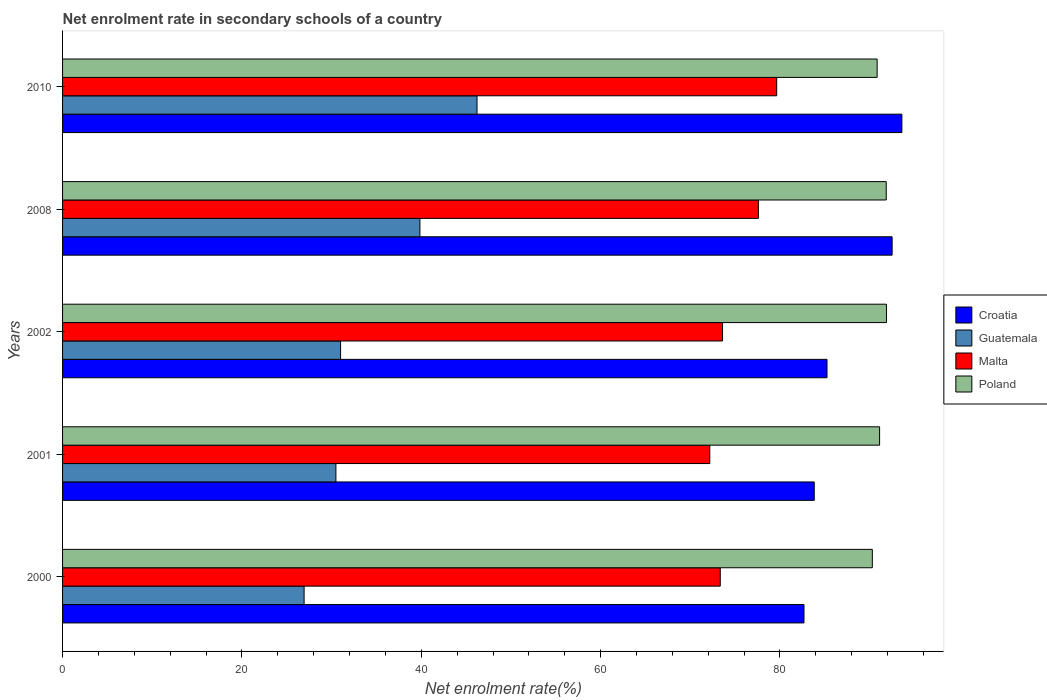How many different coloured bars are there?
Provide a short and direct response. 4. Are the number of bars per tick equal to the number of legend labels?
Make the answer very short. Yes. How many bars are there on the 3rd tick from the top?
Your response must be concise. 4. In how many cases, is the number of bars for a given year not equal to the number of legend labels?
Your response must be concise. 0. What is the net enrolment rate in secondary schools in Croatia in 2008?
Provide a succinct answer. 92.51. Across all years, what is the maximum net enrolment rate in secondary schools in Malta?
Offer a terse response. 79.63. Across all years, what is the minimum net enrolment rate in secondary schools in Malta?
Ensure brevity in your answer.  72.17. In which year was the net enrolment rate in secondary schools in Croatia minimum?
Offer a terse response. 2000. What is the total net enrolment rate in secondary schools in Croatia in the graph?
Provide a short and direct response. 437.85. What is the difference between the net enrolment rate in secondary schools in Guatemala in 2002 and that in 2008?
Give a very brief answer. -8.85. What is the difference between the net enrolment rate in secondary schools in Poland in 2008 and the net enrolment rate in secondary schools in Croatia in 2002?
Keep it short and to the point. 6.6. What is the average net enrolment rate in secondary schools in Malta per year?
Make the answer very short. 75.27. In the year 2008, what is the difference between the net enrolment rate in secondary schools in Poland and net enrolment rate in secondary schools in Malta?
Provide a succinct answer. 14.26. What is the ratio of the net enrolment rate in secondary schools in Poland in 2000 to that in 2008?
Ensure brevity in your answer.  0.98. Is the net enrolment rate in secondary schools in Malta in 2008 less than that in 2010?
Offer a terse response. Yes. Is the difference between the net enrolment rate in secondary schools in Poland in 2001 and 2010 greater than the difference between the net enrolment rate in secondary schools in Malta in 2001 and 2010?
Your answer should be very brief. Yes. What is the difference between the highest and the second highest net enrolment rate in secondary schools in Poland?
Give a very brief answer. 0.03. What is the difference between the highest and the lowest net enrolment rate in secondary schools in Malta?
Offer a terse response. 7.46. In how many years, is the net enrolment rate in secondary schools in Poland greater than the average net enrolment rate in secondary schools in Poland taken over all years?
Your response must be concise. 2. Is it the case that in every year, the sum of the net enrolment rate in secondary schools in Malta and net enrolment rate in secondary schools in Poland is greater than the sum of net enrolment rate in secondary schools in Croatia and net enrolment rate in secondary schools in Guatemala?
Provide a short and direct response. Yes. What does the 2nd bar from the top in 2002 represents?
Give a very brief answer. Malta. What does the 3rd bar from the bottom in 2002 represents?
Your response must be concise. Malta. Is it the case that in every year, the sum of the net enrolment rate in secondary schools in Guatemala and net enrolment rate in secondary schools in Croatia is greater than the net enrolment rate in secondary schools in Poland?
Your response must be concise. Yes. Are all the bars in the graph horizontal?
Ensure brevity in your answer.  Yes. What is the difference between two consecutive major ticks on the X-axis?
Your answer should be compact. 20. Are the values on the major ticks of X-axis written in scientific E-notation?
Ensure brevity in your answer.  No. Does the graph contain any zero values?
Your response must be concise. No. Does the graph contain grids?
Provide a succinct answer. No. How are the legend labels stacked?
Offer a terse response. Vertical. What is the title of the graph?
Provide a succinct answer. Net enrolment rate in secondary schools of a country. Does "Other small states" appear as one of the legend labels in the graph?
Your answer should be compact. No. What is the label or title of the X-axis?
Offer a terse response. Net enrolment rate(%). What is the Net enrolment rate(%) in Croatia in 2000?
Your answer should be compact. 82.68. What is the Net enrolment rate(%) of Guatemala in 2000?
Your answer should be compact. 26.94. What is the Net enrolment rate(%) of Malta in 2000?
Your answer should be compact. 73.34. What is the Net enrolment rate(%) in Poland in 2000?
Give a very brief answer. 90.3. What is the Net enrolment rate(%) in Croatia in 2001?
Make the answer very short. 83.82. What is the Net enrolment rate(%) in Guatemala in 2001?
Give a very brief answer. 30.48. What is the Net enrolment rate(%) of Malta in 2001?
Keep it short and to the point. 72.17. What is the Net enrolment rate(%) in Poland in 2001?
Your response must be concise. 91.11. What is the Net enrolment rate(%) of Croatia in 2002?
Offer a very short reply. 85.25. What is the Net enrolment rate(%) in Guatemala in 2002?
Give a very brief answer. 31. What is the Net enrolment rate(%) of Malta in 2002?
Your response must be concise. 73.6. What is the Net enrolment rate(%) of Poland in 2002?
Offer a terse response. 91.88. What is the Net enrolment rate(%) in Croatia in 2008?
Give a very brief answer. 92.51. What is the Net enrolment rate(%) of Guatemala in 2008?
Make the answer very short. 39.85. What is the Net enrolment rate(%) of Malta in 2008?
Your answer should be compact. 77.59. What is the Net enrolment rate(%) of Poland in 2008?
Offer a terse response. 91.85. What is the Net enrolment rate(%) of Croatia in 2010?
Provide a short and direct response. 93.59. What is the Net enrolment rate(%) of Guatemala in 2010?
Your response must be concise. 46.22. What is the Net enrolment rate(%) of Malta in 2010?
Offer a very short reply. 79.63. What is the Net enrolment rate(%) of Poland in 2010?
Keep it short and to the point. 90.84. Across all years, what is the maximum Net enrolment rate(%) in Croatia?
Give a very brief answer. 93.59. Across all years, what is the maximum Net enrolment rate(%) of Guatemala?
Provide a short and direct response. 46.22. Across all years, what is the maximum Net enrolment rate(%) of Malta?
Provide a short and direct response. 79.63. Across all years, what is the maximum Net enrolment rate(%) of Poland?
Your answer should be compact. 91.88. Across all years, what is the minimum Net enrolment rate(%) in Croatia?
Ensure brevity in your answer.  82.68. Across all years, what is the minimum Net enrolment rate(%) of Guatemala?
Keep it short and to the point. 26.94. Across all years, what is the minimum Net enrolment rate(%) of Malta?
Give a very brief answer. 72.17. Across all years, what is the minimum Net enrolment rate(%) in Poland?
Give a very brief answer. 90.3. What is the total Net enrolment rate(%) of Croatia in the graph?
Your answer should be very brief. 437.85. What is the total Net enrolment rate(%) of Guatemala in the graph?
Ensure brevity in your answer.  174.49. What is the total Net enrolment rate(%) in Malta in the graph?
Provide a short and direct response. 376.34. What is the total Net enrolment rate(%) of Poland in the graph?
Keep it short and to the point. 455.97. What is the difference between the Net enrolment rate(%) of Croatia in 2000 and that in 2001?
Offer a terse response. -1.14. What is the difference between the Net enrolment rate(%) of Guatemala in 2000 and that in 2001?
Your answer should be compact. -3.55. What is the difference between the Net enrolment rate(%) of Malta in 2000 and that in 2001?
Provide a succinct answer. 1.17. What is the difference between the Net enrolment rate(%) of Poland in 2000 and that in 2001?
Offer a terse response. -0.81. What is the difference between the Net enrolment rate(%) in Croatia in 2000 and that in 2002?
Your answer should be compact. -2.57. What is the difference between the Net enrolment rate(%) in Guatemala in 2000 and that in 2002?
Give a very brief answer. -4.07. What is the difference between the Net enrolment rate(%) of Malta in 2000 and that in 2002?
Keep it short and to the point. -0.25. What is the difference between the Net enrolment rate(%) of Poland in 2000 and that in 2002?
Make the answer very short. -1.58. What is the difference between the Net enrolment rate(%) in Croatia in 2000 and that in 2008?
Keep it short and to the point. -9.83. What is the difference between the Net enrolment rate(%) of Guatemala in 2000 and that in 2008?
Give a very brief answer. -12.91. What is the difference between the Net enrolment rate(%) of Malta in 2000 and that in 2008?
Offer a terse response. -4.25. What is the difference between the Net enrolment rate(%) in Poland in 2000 and that in 2008?
Give a very brief answer. -1.55. What is the difference between the Net enrolment rate(%) in Croatia in 2000 and that in 2010?
Your answer should be very brief. -10.91. What is the difference between the Net enrolment rate(%) of Guatemala in 2000 and that in 2010?
Offer a very short reply. -19.28. What is the difference between the Net enrolment rate(%) of Malta in 2000 and that in 2010?
Provide a succinct answer. -6.29. What is the difference between the Net enrolment rate(%) of Poland in 2000 and that in 2010?
Make the answer very short. -0.54. What is the difference between the Net enrolment rate(%) in Croatia in 2001 and that in 2002?
Your response must be concise. -1.42. What is the difference between the Net enrolment rate(%) of Guatemala in 2001 and that in 2002?
Your answer should be compact. -0.52. What is the difference between the Net enrolment rate(%) of Malta in 2001 and that in 2002?
Provide a succinct answer. -1.42. What is the difference between the Net enrolment rate(%) of Poland in 2001 and that in 2002?
Offer a very short reply. -0.77. What is the difference between the Net enrolment rate(%) of Croatia in 2001 and that in 2008?
Ensure brevity in your answer.  -8.69. What is the difference between the Net enrolment rate(%) of Guatemala in 2001 and that in 2008?
Provide a succinct answer. -9.37. What is the difference between the Net enrolment rate(%) of Malta in 2001 and that in 2008?
Give a very brief answer. -5.42. What is the difference between the Net enrolment rate(%) in Poland in 2001 and that in 2008?
Keep it short and to the point. -0.74. What is the difference between the Net enrolment rate(%) of Croatia in 2001 and that in 2010?
Make the answer very short. -9.77. What is the difference between the Net enrolment rate(%) of Guatemala in 2001 and that in 2010?
Offer a terse response. -15.74. What is the difference between the Net enrolment rate(%) of Malta in 2001 and that in 2010?
Offer a terse response. -7.46. What is the difference between the Net enrolment rate(%) in Poland in 2001 and that in 2010?
Provide a short and direct response. 0.27. What is the difference between the Net enrolment rate(%) in Croatia in 2002 and that in 2008?
Make the answer very short. -7.26. What is the difference between the Net enrolment rate(%) in Guatemala in 2002 and that in 2008?
Ensure brevity in your answer.  -8.85. What is the difference between the Net enrolment rate(%) of Malta in 2002 and that in 2008?
Keep it short and to the point. -4. What is the difference between the Net enrolment rate(%) of Poland in 2002 and that in 2008?
Provide a succinct answer. 0.03. What is the difference between the Net enrolment rate(%) in Croatia in 2002 and that in 2010?
Offer a terse response. -8.35. What is the difference between the Net enrolment rate(%) of Guatemala in 2002 and that in 2010?
Offer a very short reply. -15.22. What is the difference between the Net enrolment rate(%) in Malta in 2002 and that in 2010?
Make the answer very short. -6.04. What is the difference between the Net enrolment rate(%) of Poland in 2002 and that in 2010?
Offer a very short reply. 1.04. What is the difference between the Net enrolment rate(%) in Croatia in 2008 and that in 2010?
Offer a terse response. -1.09. What is the difference between the Net enrolment rate(%) in Guatemala in 2008 and that in 2010?
Provide a succinct answer. -6.37. What is the difference between the Net enrolment rate(%) in Malta in 2008 and that in 2010?
Provide a short and direct response. -2.04. What is the difference between the Net enrolment rate(%) of Poland in 2008 and that in 2010?
Offer a terse response. 1.01. What is the difference between the Net enrolment rate(%) in Croatia in 2000 and the Net enrolment rate(%) in Guatemala in 2001?
Keep it short and to the point. 52.2. What is the difference between the Net enrolment rate(%) in Croatia in 2000 and the Net enrolment rate(%) in Malta in 2001?
Give a very brief answer. 10.51. What is the difference between the Net enrolment rate(%) in Croatia in 2000 and the Net enrolment rate(%) in Poland in 2001?
Provide a short and direct response. -8.43. What is the difference between the Net enrolment rate(%) of Guatemala in 2000 and the Net enrolment rate(%) of Malta in 2001?
Provide a short and direct response. -45.24. What is the difference between the Net enrolment rate(%) of Guatemala in 2000 and the Net enrolment rate(%) of Poland in 2001?
Offer a terse response. -64.17. What is the difference between the Net enrolment rate(%) in Malta in 2000 and the Net enrolment rate(%) in Poland in 2001?
Offer a very short reply. -17.77. What is the difference between the Net enrolment rate(%) in Croatia in 2000 and the Net enrolment rate(%) in Guatemala in 2002?
Your response must be concise. 51.68. What is the difference between the Net enrolment rate(%) in Croatia in 2000 and the Net enrolment rate(%) in Malta in 2002?
Provide a short and direct response. 9.08. What is the difference between the Net enrolment rate(%) of Croatia in 2000 and the Net enrolment rate(%) of Poland in 2002?
Offer a terse response. -9.2. What is the difference between the Net enrolment rate(%) of Guatemala in 2000 and the Net enrolment rate(%) of Malta in 2002?
Give a very brief answer. -46.66. What is the difference between the Net enrolment rate(%) of Guatemala in 2000 and the Net enrolment rate(%) of Poland in 2002?
Give a very brief answer. -64.94. What is the difference between the Net enrolment rate(%) of Malta in 2000 and the Net enrolment rate(%) of Poland in 2002?
Your response must be concise. -18.53. What is the difference between the Net enrolment rate(%) in Croatia in 2000 and the Net enrolment rate(%) in Guatemala in 2008?
Keep it short and to the point. 42.83. What is the difference between the Net enrolment rate(%) of Croatia in 2000 and the Net enrolment rate(%) of Malta in 2008?
Offer a very short reply. 5.09. What is the difference between the Net enrolment rate(%) of Croatia in 2000 and the Net enrolment rate(%) of Poland in 2008?
Make the answer very short. -9.17. What is the difference between the Net enrolment rate(%) of Guatemala in 2000 and the Net enrolment rate(%) of Malta in 2008?
Your answer should be very brief. -50.66. What is the difference between the Net enrolment rate(%) of Guatemala in 2000 and the Net enrolment rate(%) of Poland in 2008?
Give a very brief answer. -64.91. What is the difference between the Net enrolment rate(%) in Malta in 2000 and the Net enrolment rate(%) in Poland in 2008?
Your answer should be compact. -18.51. What is the difference between the Net enrolment rate(%) of Croatia in 2000 and the Net enrolment rate(%) of Guatemala in 2010?
Provide a succinct answer. 36.46. What is the difference between the Net enrolment rate(%) in Croatia in 2000 and the Net enrolment rate(%) in Malta in 2010?
Make the answer very short. 3.04. What is the difference between the Net enrolment rate(%) in Croatia in 2000 and the Net enrolment rate(%) in Poland in 2010?
Give a very brief answer. -8.16. What is the difference between the Net enrolment rate(%) of Guatemala in 2000 and the Net enrolment rate(%) of Malta in 2010?
Your response must be concise. -52.7. What is the difference between the Net enrolment rate(%) in Guatemala in 2000 and the Net enrolment rate(%) in Poland in 2010?
Give a very brief answer. -63.9. What is the difference between the Net enrolment rate(%) of Malta in 2000 and the Net enrolment rate(%) of Poland in 2010?
Your response must be concise. -17.49. What is the difference between the Net enrolment rate(%) of Croatia in 2001 and the Net enrolment rate(%) of Guatemala in 2002?
Your response must be concise. 52.82. What is the difference between the Net enrolment rate(%) of Croatia in 2001 and the Net enrolment rate(%) of Malta in 2002?
Make the answer very short. 10.23. What is the difference between the Net enrolment rate(%) in Croatia in 2001 and the Net enrolment rate(%) in Poland in 2002?
Make the answer very short. -8.05. What is the difference between the Net enrolment rate(%) of Guatemala in 2001 and the Net enrolment rate(%) of Malta in 2002?
Provide a short and direct response. -43.11. What is the difference between the Net enrolment rate(%) of Guatemala in 2001 and the Net enrolment rate(%) of Poland in 2002?
Keep it short and to the point. -61.39. What is the difference between the Net enrolment rate(%) of Malta in 2001 and the Net enrolment rate(%) of Poland in 2002?
Your answer should be compact. -19.7. What is the difference between the Net enrolment rate(%) of Croatia in 2001 and the Net enrolment rate(%) of Guatemala in 2008?
Provide a succinct answer. 43.97. What is the difference between the Net enrolment rate(%) of Croatia in 2001 and the Net enrolment rate(%) of Malta in 2008?
Offer a very short reply. 6.23. What is the difference between the Net enrolment rate(%) of Croatia in 2001 and the Net enrolment rate(%) of Poland in 2008?
Your response must be concise. -8.03. What is the difference between the Net enrolment rate(%) in Guatemala in 2001 and the Net enrolment rate(%) in Malta in 2008?
Your response must be concise. -47.11. What is the difference between the Net enrolment rate(%) of Guatemala in 2001 and the Net enrolment rate(%) of Poland in 2008?
Offer a very short reply. -61.37. What is the difference between the Net enrolment rate(%) in Malta in 2001 and the Net enrolment rate(%) in Poland in 2008?
Your response must be concise. -19.68. What is the difference between the Net enrolment rate(%) of Croatia in 2001 and the Net enrolment rate(%) of Guatemala in 2010?
Provide a succinct answer. 37.61. What is the difference between the Net enrolment rate(%) of Croatia in 2001 and the Net enrolment rate(%) of Malta in 2010?
Ensure brevity in your answer.  4.19. What is the difference between the Net enrolment rate(%) of Croatia in 2001 and the Net enrolment rate(%) of Poland in 2010?
Ensure brevity in your answer.  -7.01. What is the difference between the Net enrolment rate(%) of Guatemala in 2001 and the Net enrolment rate(%) of Malta in 2010?
Give a very brief answer. -49.15. What is the difference between the Net enrolment rate(%) in Guatemala in 2001 and the Net enrolment rate(%) in Poland in 2010?
Make the answer very short. -60.35. What is the difference between the Net enrolment rate(%) of Malta in 2001 and the Net enrolment rate(%) of Poland in 2010?
Your answer should be very brief. -18.66. What is the difference between the Net enrolment rate(%) of Croatia in 2002 and the Net enrolment rate(%) of Guatemala in 2008?
Your answer should be compact. 45.4. What is the difference between the Net enrolment rate(%) of Croatia in 2002 and the Net enrolment rate(%) of Malta in 2008?
Your answer should be very brief. 7.65. What is the difference between the Net enrolment rate(%) of Croatia in 2002 and the Net enrolment rate(%) of Poland in 2008?
Ensure brevity in your answer.  -6.6. What is the difference between the Net enrolment rate(%) of Guatemala in 2002 and the Net enrolment rate(%) of Malta in 2008?
Offer a terse response. -46.59. What is the difference between the Net enrolment rate(%) of Guatemala in 2002 and the Net enrolment rate(%) of Poland in 2008?
Your response must be concise. -60.85. What is the difference between the Net enrolment rate(%) in Malta in 2002 and the Net enrolment rate(%) in Poland in 2008?
Offer a terse response. -18.25. What is the difference between the Net enrolment rate(%) in Croatia in 2002 and the Net enrolment rate(%) in Guatemala in 2010?
Provide a succinct answer. 39.03. What is the difference between the Net enrolment rate(%) in Croatia in 2002 and the Net enrolment rate(%) in Malta in 2010?
Provide a succinct answer. 5.61. What is the difference between the Net enrolment rate(%) of Croatia in 2002 and the Net enrolment rate(%) of Poland in 2010?
Offer a very short reply. -5.59. What is the difference between the Net enrolment rate(%) in Guatemala in 2002 and the Net enrolment rate(%) in Malta in 2010?
Your answer should be compact. -48.63. What is the difference between the Net enrolment rate(%) of Guatemala in 2002 and the Net enrolment rate(%) of Poland in 2010?
Your answer should be very brief. -59.83. What is the difference between the Net enrolment rate(%) in Malta in 2002 and the Net enrolment rate(%) in Poland in 2010?
Ensure brevity in your answer.  -17.24. What is the difference between the Net enrolment rate(%) of Croatia in 2008 and the Net enrolment rate(%) of Guatemala in 2010?
Your response must be concise. 46.29. What is the difference between the Net enrolment rate(%) in Croatia in 2008 and the Net enrolment rate(%) in Malta in 2010?
Keep it short and to the point. 12.87. What is the difference between the Net enrolment rate(%) of Croatia in 2008 and the Net enrolment rate(%) of Poland in 2010?
Provide a succinct answer. 1.67. What is the difference between the Net enrolment rate(%) in Guatemala in 2008 and the Net enrolment rate(%) in Malta in 2010?
Offer a very short reply. -39.78. What is the difference between the Net enrolment rate(%) in Guatemala in 2008 and the Net enrolment rate(%) in Poland in 2010?
Ensure brevity in your answer.  -50.99. What is the difference between the Net enrolment rate(%) in Malta in 2008 and the Net enrolment rate(%) in Poland in 2010?
Offer a very short reply. -13.24. What is the average Net enrolment rate(%) in Croatia per year?
Give a very brief answer. 87.57. What is the average Net enrolment rate(%) in Guatemala per year?
Make the answer very short. 34.9. What is the average Net enrolment rate(%) of Malta per year?
Provide a succinct answer. 75.27. What is the average Net enrolment rate(%) of Poland per year?
Your response must be concise. 91.19. In the year 2000, what is the difference between the Net enrolment rate(%) of Croatia and Net enrolment rate(%) of Guatemala?
Give a very brief answer. 55.74. In the year 2000, what is the difference between the Net enrolment rate(%) of Croatia and Net enrolment rate(%) of Malta?
Make the answer very short. 9.34. In the year 2000, what is the difference between the Net enrolment rate(%) of Croatia and Net enrolment rate(%) of Poland?
Your response must be concise. -7.62. In the year 2000, what is the difference between the Net enrolment rate(%) of Guatemala and Net enrolment rate(%) of Malta?
Offer a very short reply. -46.41. In the year 2000, what is the difference between the Net enrolment rate(%) in Guatemala and Net enrolment rate(%) in Poland?
Keep it short and to the point. -63.36. In the year 2000, what is the difference between the Net enrolment rate(%) of Malta and Net enrolment rate(%) of Poland?
Offer a terse response. -16.96. In the year 2001, what is the difference between the Net enrolment rate(%) in Croatia and Net enrolment rate(%) in Guatemala?
Give a very brief answer. 53.34. In the year 2001, what is the difference between the Net enrolment rate(%) of Croatia and Net enrolment rate(%) of Malta?
Make the answer very short. 11.65. In the year 2001, what is the difference between the Net enrolment rate(%) in Croatia and Net enrolment rate(%) in Poland?
Make the answer very short. -7.29. In the year 2001, what is the difference between the Net enrolment rate(%) of Guatemala and Net enrolment rate(%) of Malta?
Keep it short and to the point. -41.69. In the year 2001, what is the difference between the Net enrolment rate(%) of Guatemala and Net enrolment rate(%) of Poland?
Your answer should be compact. -60.63. In the year 2001, what is the difference between the Net enrolment rate(%) in Malta and Net enrolment rate(%) in Poland?
Your answer should be compact. -18.94. In the year 2002, what is the difference between the Net enrolment rate(%) of Croatia and Net enrolment rate(%) of Guatemala?
Ensure brevity in your answer.  54.24. In the year 2002, what is the difference between the Net enrolment rate(%) in Croatia and Net enrolment rate(%) in Malta?
Your response must be concise. 11.65. In the year 2002, what is the difference between the Net enrolment rate(%) in Croatia and Net enrolment rate(%) in Poland?
Provide a short and direct response. -6.63. In the year 2002, what is the difference between the Net enrolment rate(%) of Guatemala and Net enrolment rate(%) of Malta?
Provide a succinct answer. -42.59. In the year 2002, what is the difference between the Net enrolment rate(%) in Guatemala and Net enrolment rate(%) in Poland?
Provide a short and direct response. -60.87. In the year 2002, what is the difference between the Net enrolment rate(%) of Malta and Net enrolment rate(%) of Poland?
Give a very brief answer. -18.28. In the year 2008, what is the difference between the Net enrolment rate(%) of Croatia and Net enrolment rate(%) of Guatemala?
Your answer should be very brief. 52.66. In the year 2008, what is the difference between the Net enrolment rate(%) in Croatia and Net enrolment rate(%) in Malta?
Offer a very short reply. 14.92. In the year 2008, what is the difference between the Net enrolment rate(%) in Croatia and Net enrolment rate(%) in Poland?
Offer a terse response. 0.66. In the year 2008, what is the difference between the Net enrolment rate(%) in Guatemala and Net enrolment rate(%) in Malta?
Ensure brevity in your answer.  -37.74. In the year 2008, what is the difference between the Net enrolment rate(%) in Guatemala and Net enrolment rate(%) in Poland?
Give a very brief answer. -52. In the year 2008, what is the difference between the Net enrolment rate(%) of Malta and Net enrolment rate(%) of Poland?
Keep it short and to the point. -14.26. In the year 2010, what is the difference between the Net enrolment rate(%) of Croatia and Net enrolment rate(%) of Guatemala?
Make the answer very short. 47.38. In the year 2010, what is the difference between the Net enrolment rate(%) in Croatia and Net enrolment rate(%) in Malta?
Ensure brevity in your answer.  13.96. In the year 2010, what is the difference between the Net enrolment rate(%) in Croatia and Net enrolment rate(%) in Poland?
Your answer should be compact. 2.76. In the year 2010, what is the difference between the Net enrolment rate(%) in Guatemala and Net enrolment rate(%) in Malta?
Offer a very short reply. -33.42. In the year 2010, what is the difference between the Net enrolment rate(%) of Guatemala and Net enrolment rate(%) of Poland?
Provide a succinct answer. -44.62. In the year 2010, what is the difference between the Net enrolment rate(%) in Malta and Net enrolment rate(%) in Poland?
Ensure brevity in your answer.  -11.2. What is the ratio of the Net enrolment rate(%) of Croatia in 2000 to that in 2001?
Provide a succinct answer. 0.99. What is the ratio of the Net enrolment rate(%) in Guatemala in 2000 to that in 2001?
Ensure brevity in your answer.  0.88. What is the ratio of the Net enrolment rate(%) in Malta in 2000 to that in 2001?
Offer a terse response. 1.02. What is the ratio of the Net enrolment rate(%) in Poland in 2000 to that in 2001?
Ensure brevity in your answer.  0.99. What is the ratio of the Net enrolment rate(%) of Croatia in 2000 to that in 2002?
Make the answer very short. 0.97. What is the ratio of the Net enrolment rate(%) in Guatemala in 2000 to that in 2002?
Make the answer very short. 0.87. What is the ratio of the Net enrolment rate(%) in Poland in 2000 to that in 2002?
Your response must be concise. 0.98. What is the ratio of the Net enrolment rate(%) of Croatia in 2000 to that in 2008?
Your response must be concise. 0.89. What is the ratio of the Net enrolment rate(%) of Guatemala in 2000 to that in 2008?
Offer a terse response. 0.68. What is the ratio of the Net enrolment rate(%) of Malta in 2000 to that in 2008?
Give a very brief answer. 0.95. What is the ratio of the Net enrolment rate(%) of Poland in 2000 to that in 2008?
Offer a terse response. 0.98. What is the ratio of the Net enrolment rate(%) of Croatia in 2000 to that in 2010?
Your response must be concise. 0.88. What is the ratio of the Net enrolment rate(%) of Guatemala in 2000 to that in 2010?
Keep it short and to the point. 0.58. What is the ratio of the Net enrolment rate(%) of Malta in 2000 to that in 2010?
Offer a terse response. 0.92. What is the ratio of the Net enrolment rate(%) of Croatia in 2001 to that in 2002?
Provide a short and direct response. 0.98. What is the ratio of the Net enrolment rate(%) in Guatemala in 2001 to that in 2002?
Offer a very short reply. 0.98. What is the ratio of the Net enrolment rate(%) in Malta in 2001 to that in 2002?
Give a very brief answer. 0.98. What is the ratio of the Net enrolment rate(%) in Poland in 2001 to that in 2002?
Give a very brief answer. 0.99. What is the ratio of the Net enrolment rate(%) of Croatia in 2001 to that in 2008?
Ensure brevity in your answer.  0.91. What is the ratio of the Net enrolment rate(%) of Guatemala in 2001 to that in 2008?
Your answer should be very brief. 0.76. What is the ratio of the Net enrolment rate(%) in Malta in 2001 to that in 2008?
Ensure brevity in your answer.  0.93. What is the ratio of the Net enrolment rate(%) in Croatia in 2001 to that in 2010?
Keep it short and to the point. 0.9. What is the ratio of the Net enrolment rate(%) in Guatemala in 2001 to that in 2010?
Provide a short and direct response. 0.66. What is the ratio of the Net enrolment rate(%) in Malta in 2001 to that in 2010?
Keep it short and to the point. 0.91. What is the ratio of the Net enrolment rate(%) in Poland in 2001 to that in 2010?
Give a very brief answer. 1. What is the ratio of the Net enrolment rate(%) in Croatia in 2002 to that in 2008?
Your answer should be compact. 0.92. What is the ratio of the Net enrolment rate(%) in Guatemala in 2002 to that in 2008?
Offer a very short reply. 0.78. What is the ratio of the Net enrolment rate(%) of Malta in 2002 to that in 2008?
Provide a succinct answer. 0.95. What is the ratio of the Net enrolment rate(%) of Poland in 2002 to that in 2008?
Keep it short and to the point. 1. What is the ratio of the Net enrolment rate(%) of Croatia in 2002 to that in 2010?
Give a very brief answer. 0.91. What is the ratio of the Net enrolment rate(%) in Guatemala in 2002 to that in 2010?
Give a very brief answer. 0.67. What is the ratio of the Net enrolment rate(%) in Malta in 2002 to that in 2010?
Keep it short and to the point. 0.92. What is the ratio of the Net enrolment rate(%) in Poland in 2002 to that in 2010?
Offer a very short reply. 1.01. What is the ratio of the Net enrolment rate(%) of Croatia in 2008 to that in 2010?
Your answer should be very brief. 0.99. What is the ratio of the Net enrolment rate(%) of Guatemala in 2008 to that in 2010?
Your answer should be compact. 0.86. What is the ratio of the Net enrolment rate(%) of Malta in 2008 to that in 2010?
Keep it short and to the point. 0.97. What is the ratio of the Net enrolment rate(%) of Poland in 2008 to that in 2010?
Your answer should be compact. 1.01. What is the difference between the highest and the second highest Net enrolment rate(%) of Croatia?
Make the answer very short. 1.09. What is the difference between the highest and the second highest Net enrolment rate(%) of Guatemala?
Ensure brevity in your answer.  6.37. What is the difference between the highest and the second highest Net enrolment rate(%) of Malta?
Make the answer very short. 2.04. What is the difference between the highest and the second highest Net enrolment rate(%) of Poland?
Make the answer very short. 0.03. What is the difference between the highest and the lowest Net enrolment rate(%) of Croatia?
Your response must be concise. 10.91. What is the difference between the highest and the lowest Net enrolment rate(%) of Guatemala?
Ensure brevity in your answer.  19.28. What is the difference between the highest and the lowest Net enrolment rate(%) of Malta?
Offer a terse response. 7.46. What is the difference between the highest and the lowest Net enrolment rate(%) in Poland?
Make the answer very short. 1.58. 